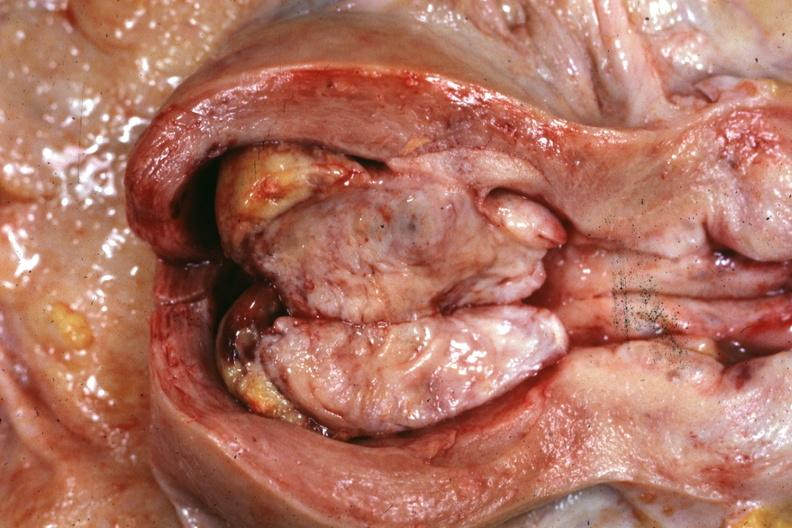s lower chest and abdomen anterior present?
Answer the question using a single word or phrase. No 